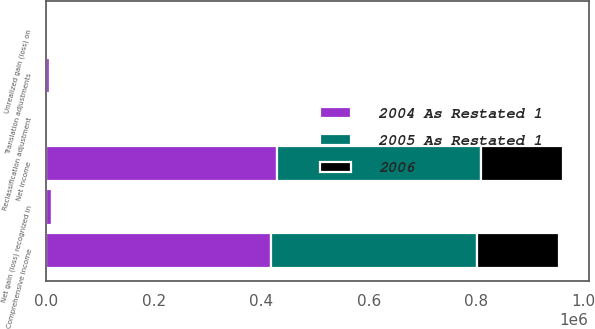<chart> <loc_0><loc_0><loc_500><loc_500><stacked_bar_chart><ecel><fcel>Net income<fcel>Unrealized gain (loss) on<fcel>Reclassification adjustment<fcel>Translation adjustments<fcel>Net gain (loss) recognized in<fcel>Comprehensive income<nl><fcel>2005 As Restated 1<fcel>379015<fcel>3382<fcel>3<fcel>776<fcel>4155<fcel>383170<nl><fcel>2004 As Restated 1<fcel>428978<fcel>4573<fcel>1419<fcel>7988<fcel>11142<fcel>417836<nl><fcel>2006<fcel>152820<fcel>3462<fcel>51<fcel>4104<fcel>591<fcel>153411<nl></chart> 